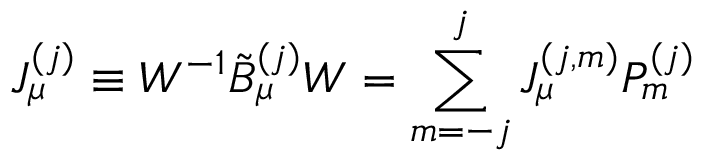<formula> <loc_0><loc_0><loc_500><loc_500>J _ { \mu } ^ { ( j ) } \equiv W ^ { - 1 } \tilde { B } _ { \mu } ^ { ( j ) } W = \sum _ { m = - j } ^ { j } J _ { \mu } ^ { ( j , m ) } P _ { m } ^ { ( j ) }</formula> 